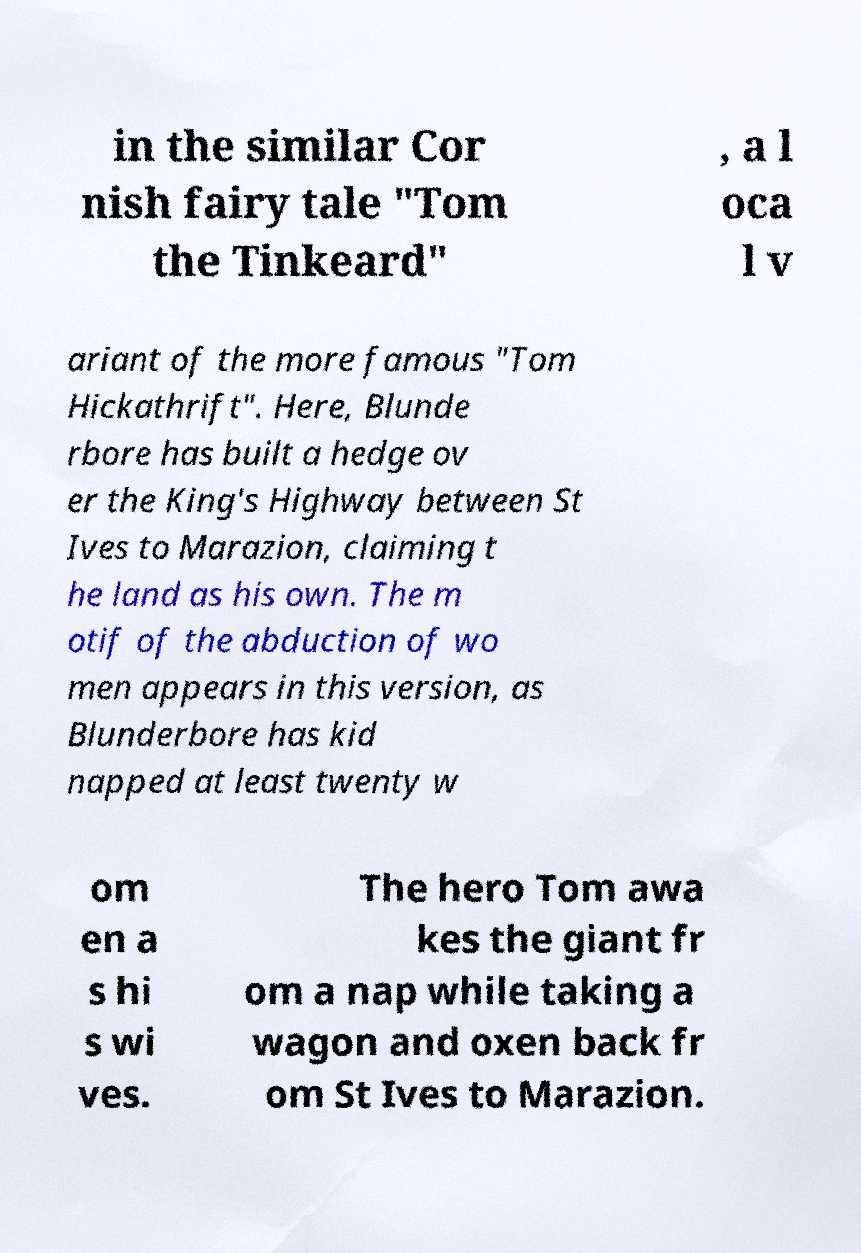I need the written content from this picture converted into text. Can you do that? in the similar Cor nish fairy tale "Tom the Tinkeard" , a l oca l v ariant of the more famous "Tom Hickathrift". Here, Blunde rbore has built a hedge ov er the King's Highway between St Ives to Marazion, claiming t he land as his own. The m otif of the abduction of wo men appears in this version, as Blunderbore has kid napped at least twenty w om en a s hi s wi ves. The hero Tom awa kes the giant fr om a nap while taking a wagon and oxen back fr om St Ives to Marazion. 